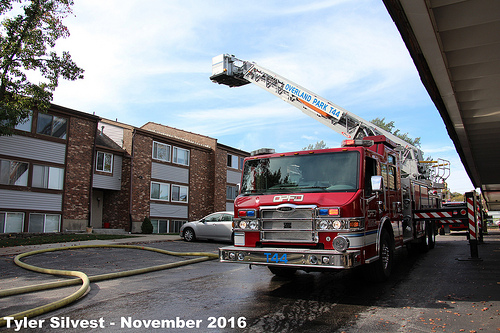<image>
Is there a firehose to the left of the tire? Yes. From this viewpoint, the firehose is positioned to the left side relative to the tire. Is there a building in front of the truck? No. The building is not in front of the truck. The spatial positioning shows a different relationship between these objects. 